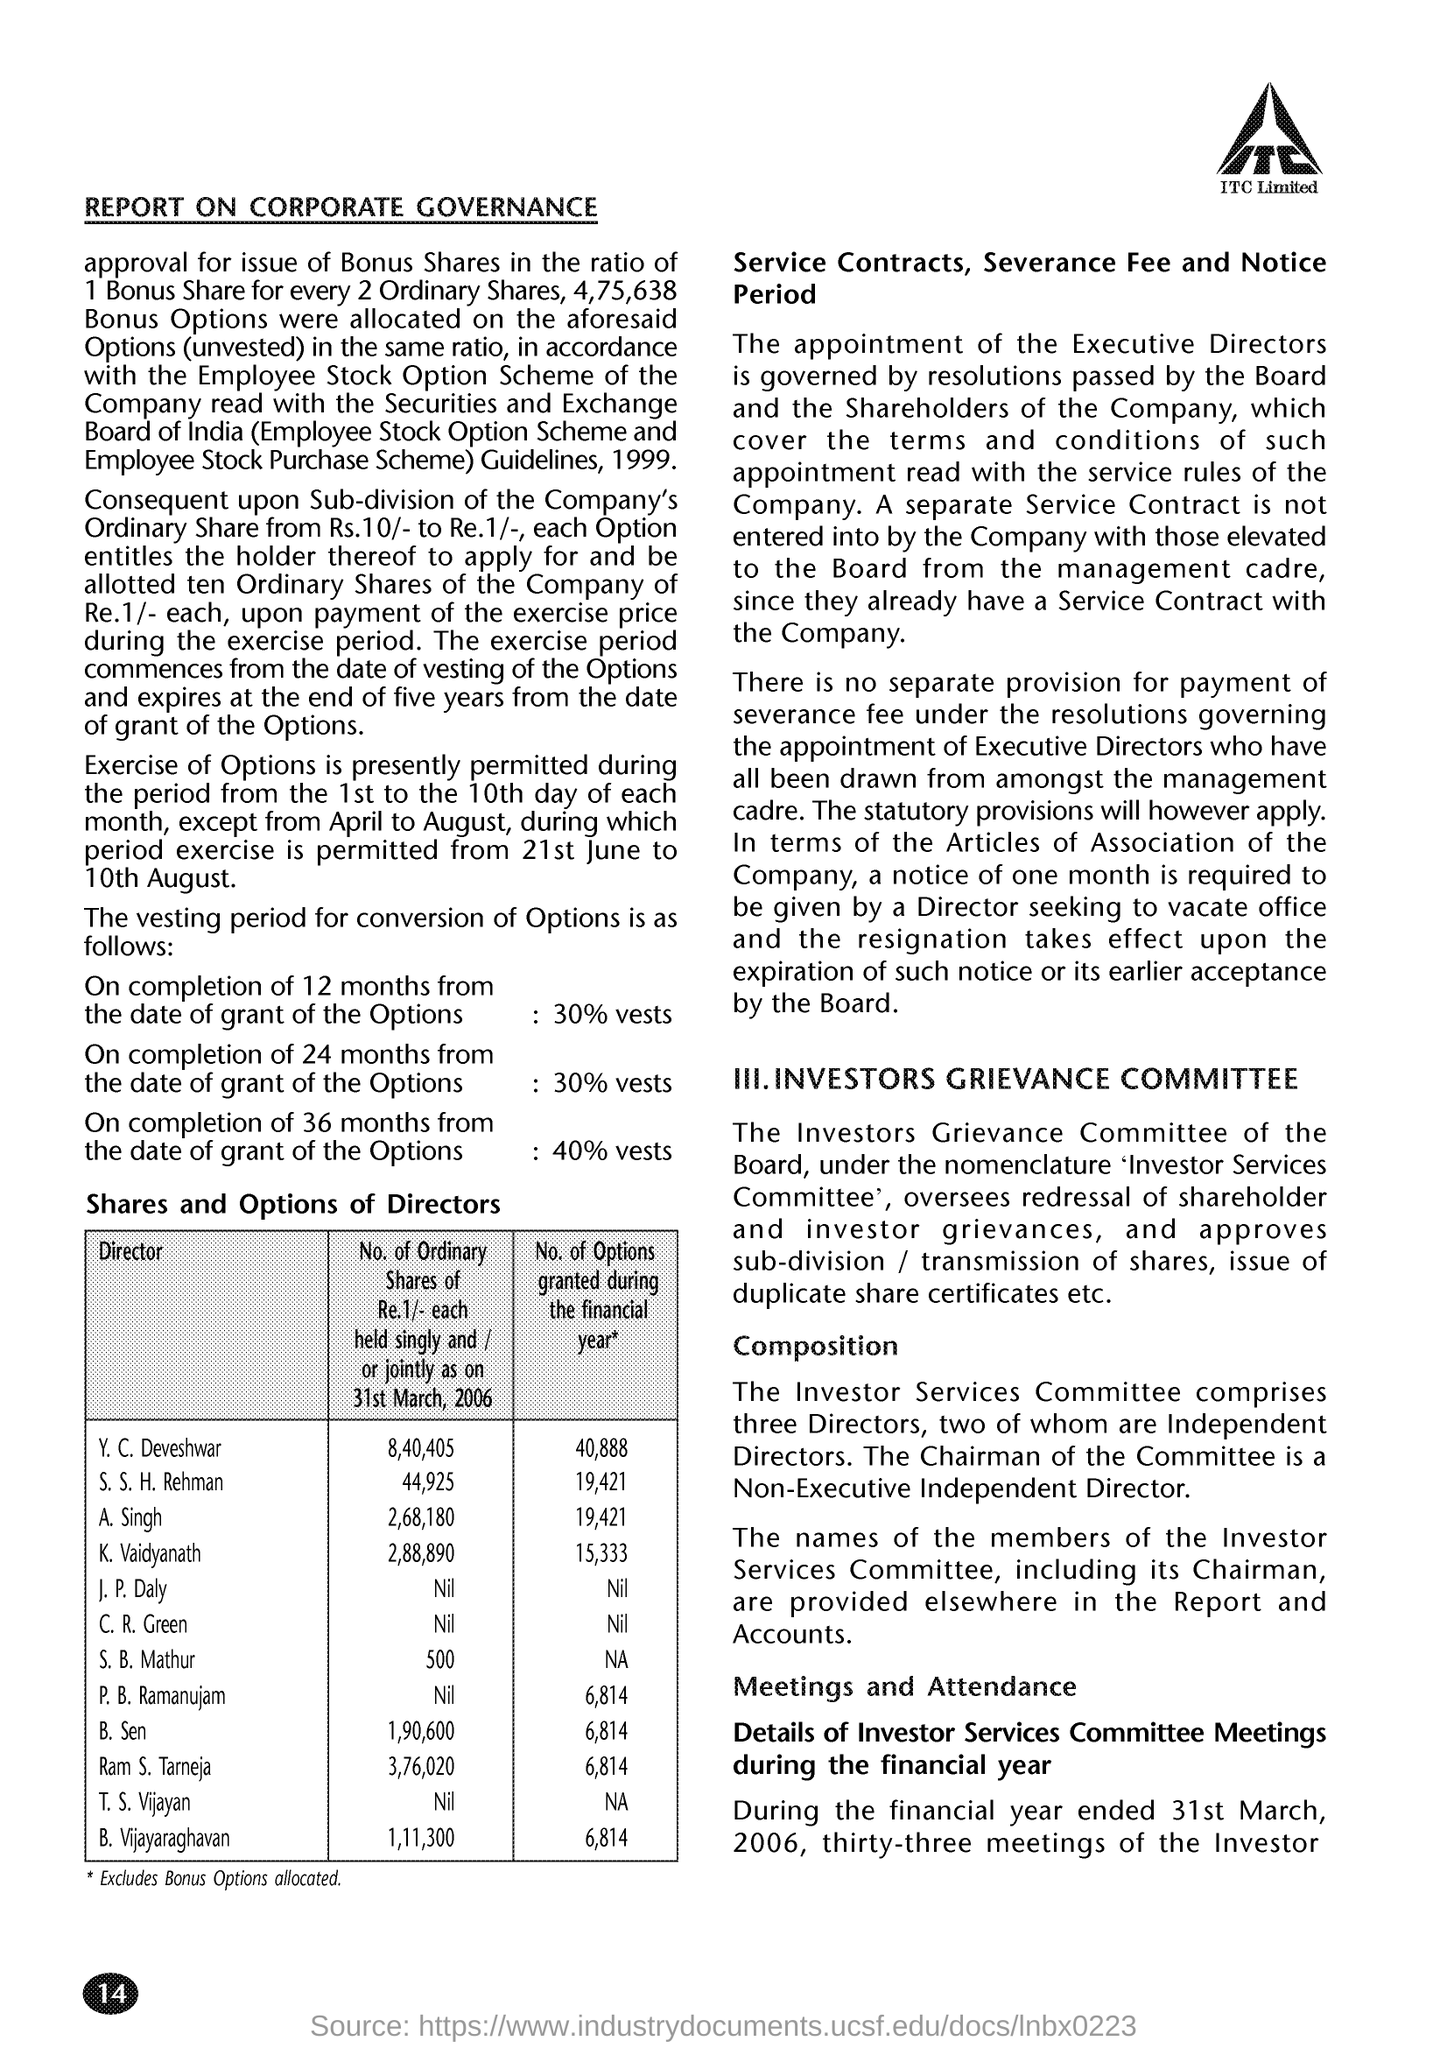What is the title of the document?
Offer a very short reply. Report on Corporate Governance. Which text is below the image?
Offer a terse response. ITC Limited. What is the Page Number?
Offer a terse response. 14. What is the maximum number of options granted during the financial year?
Keep it short and to the point. 40,888. What is the name of the director when the number of options granted during the financial year is 15,333??
Provide a succinct answer. K. Vaidyanath. 